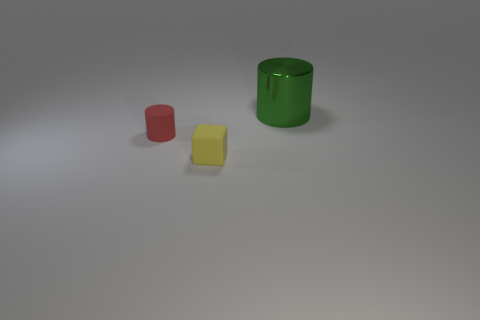Add 3 yellow shiny balls. How many objects exist? 6 Subtract all green cylinders. How many cylinders are left? 1 Subtract all cylinders. How many objects are left? 1 Subtract all blue cylinders. Subtract all cyan balls. How many cylinders are left? 2 Subtract all yellow things. Subtract all yellow matte objects. How many objects are left? 1 Add 2 small red matte cylinders. How many small red matte cylinders are left? 3 Add 3 tiny cyan shiny cylinders. How many tiny cyan shiny cylinders exist? 3 Subtract 0 green balls. How many objects are left? 3 